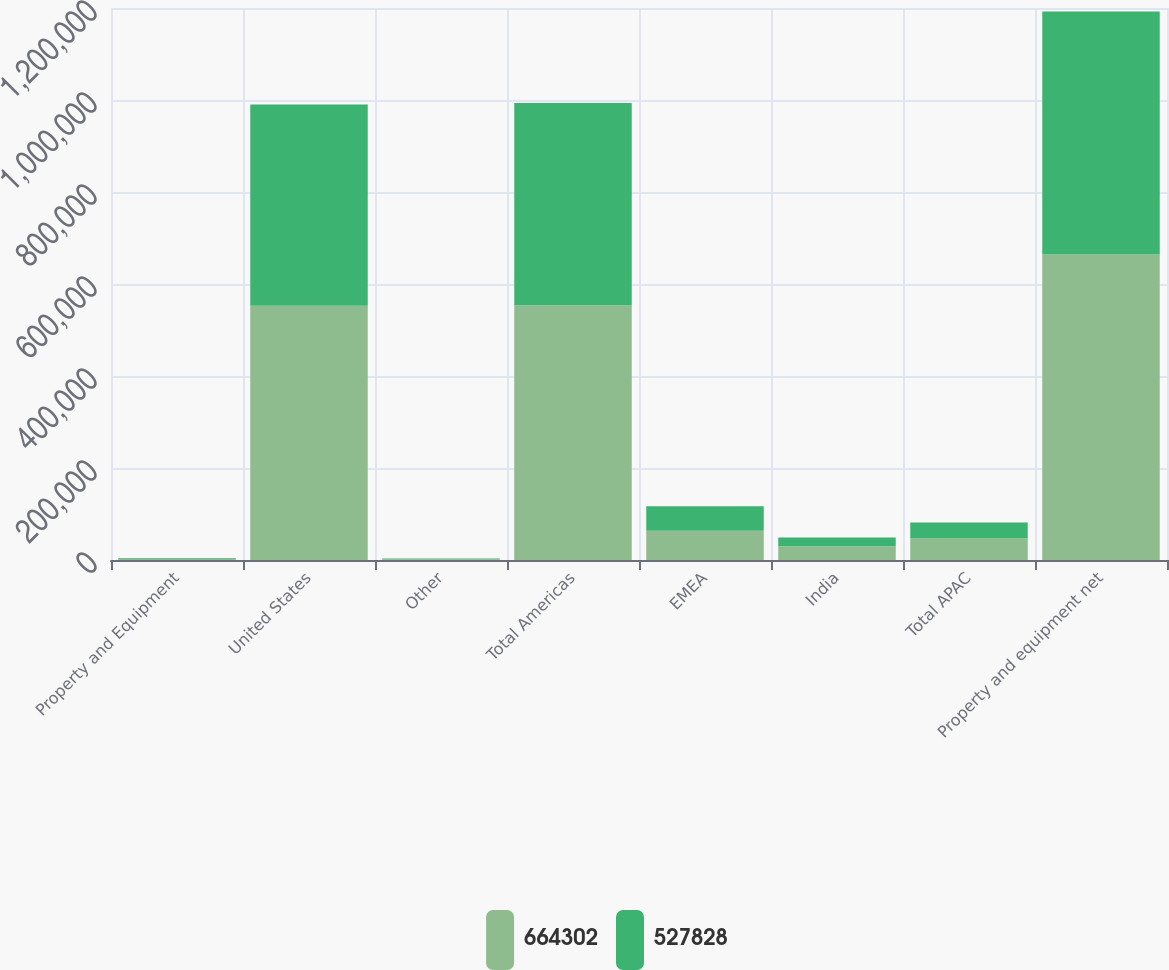Convert chart. <chart><loc_0><loc_0><loc_500><loc_500><stacked_bar_chart><ecel><fcel>Property and Equipment<fcel>United States<fcel>Other<fcel>Total Americas<fcel>EMEA<fcel>India<fcel>Total APAC<fcel>Property and equipment net<nl><fcel>664302<fcel>2012<fcel>552634<fcel>1426<fcel>554060<fcel>63515<fcel>30007<fcel>46727<fcel>664302<nl><fcel>527828<fcel>2011<fcel>437701<fcel>1926<fcel>439627<fcel>53474<fcel>18955<fcel>34727<fcel>527828<nl></chart> 